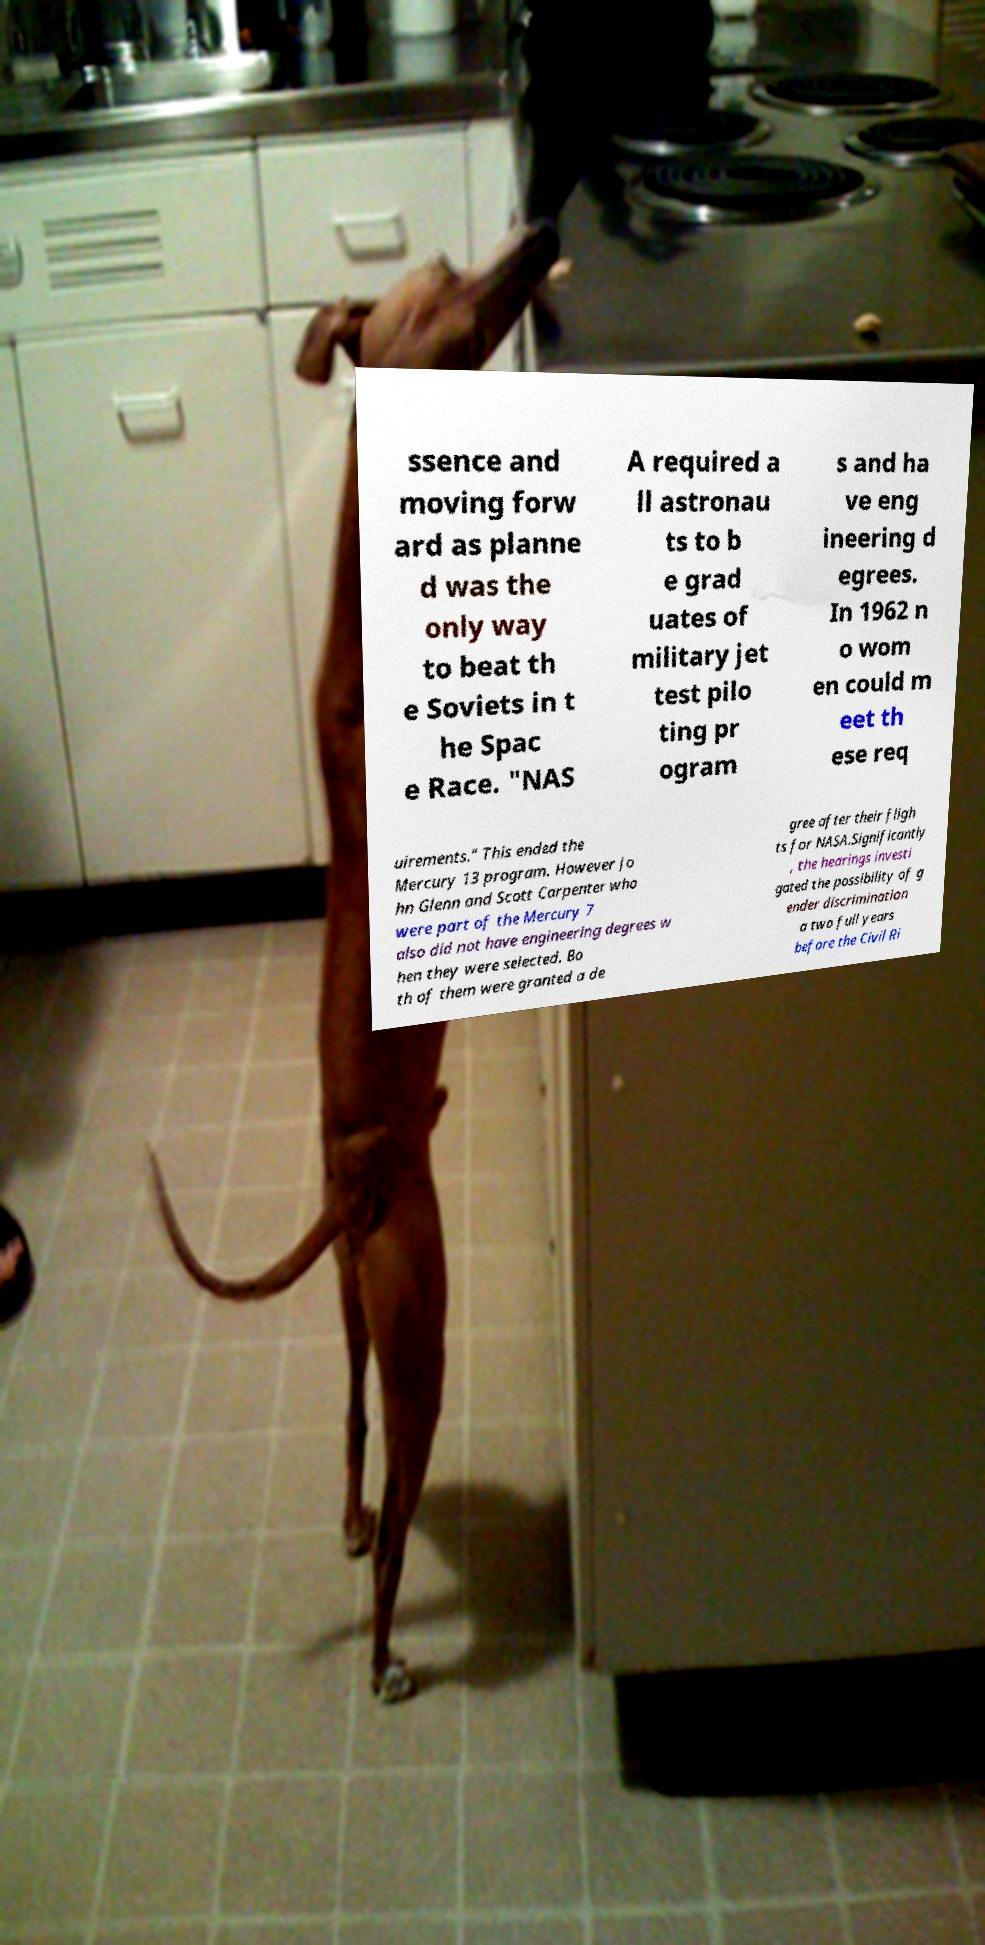There's text embedded in this image that I need extracted. Can you transcribe it verbatim? ssence and moving forw ard as planne d was the only way to beat th e Soviets in t he Spac e Race. "NAS A required a ll astronau ts to b e grad uates of military jet test pilo ting pr ogram s and ha ve eng ineering d egrees. In 1962 n o wom en could m eet th ese req uirements." This ended the Mercury 13 program. However Jo hn Glenn and Scott Carpenter who were part of the Mercury 7 also did not have engineering degrees w hen they were selected. Bo th of them were granted a de gree after their fligh ts for NASA.Significantly , the hearings investi gated the possibility of g ender discrimination a two full years before the Civil Ri 